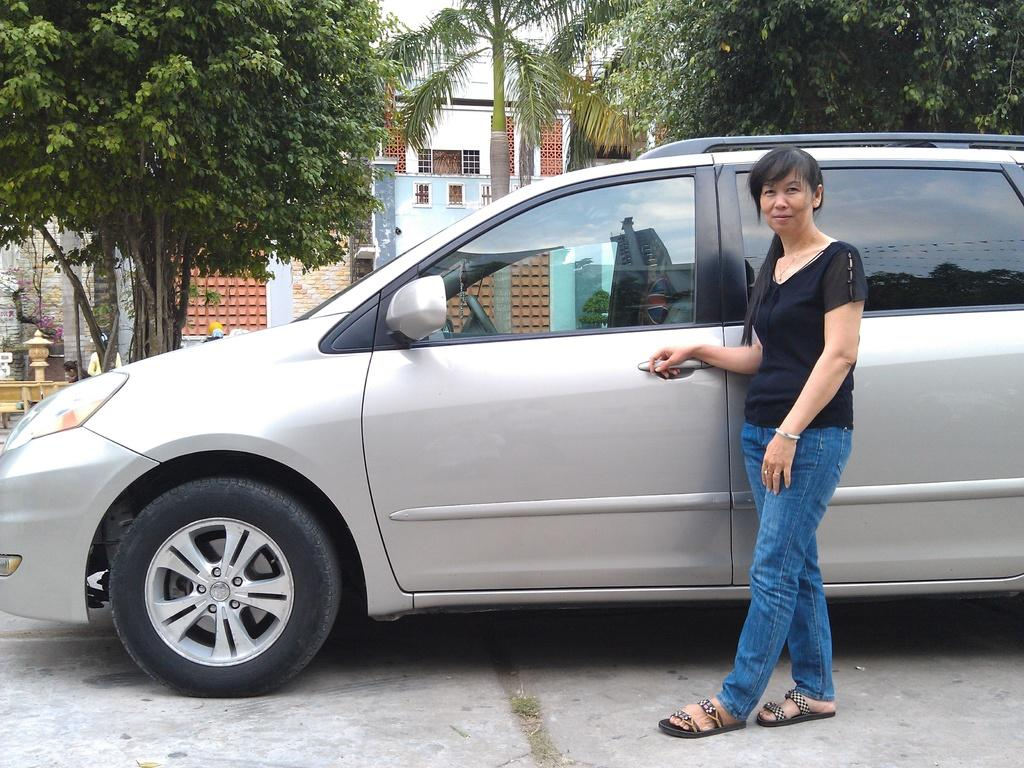What is the woman doing in the image? The woman is standing behind a car in the image. What can be seen in the background of the image? There is a building in the background of the image. What type of vegetation is visible in the middle of the image? There are trees visible in the middle of the image. What is visible at the top of the image? The sky is visible at the top of the image. What type of rose is the woman holding in the image? There is no rose present in the image; the woman is standing behind a car. What is the woman writing on the car in the image? There is no indication that the woman is writing on the car in the image. 